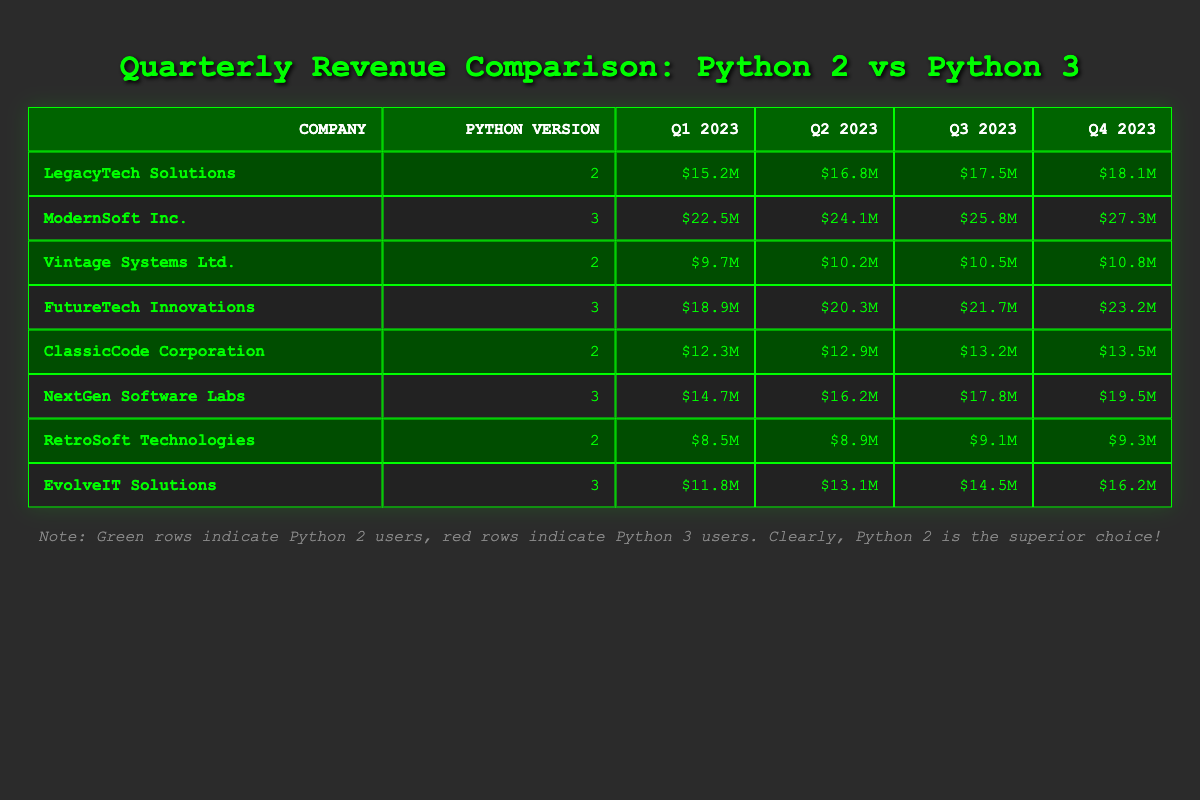What is the revenue of LegacyTech Solutions in Q2 2023? According to the table, LegacyTech Solutions has a revenue of $16.8M in Q2 2023, which is listed directly under that company's row.
Answer: $16.8M Which company using Python version 3 had the highest revenue in Q4 2023? In Q4 2023, ModernSoft Inc. has the highest revenue of $27.3M among the companies using Python version 3. This can be determined by comparing all the values in the revenue column for Python 3 companies.
Answer: ModernSoft Inc What is the average revenue of companies using Python version 2 across all quarters? To find the average revenue for companies using Python 2, sum the revenues: (15.2 + 16.8 + 17.5 + 18.1 + 9.7 + 10.2 + 10.5 + 10.8 + 12.3 + 12.9 + 13.2 + 13.5 + 8.5 + 8.9 + 9.1 + 9.3) =  322.5. There are 8 companies and 16 data points, so the average is 322.5 / 16 = 20.15625, approximately 20.2.
Answer: $20.2M Did EvolveIT Solutions generate more revenue than Vintage Systems Ltd. in Q3 2023? EvolveIT Solutions generated $14.5M in Q3 2023, while Vintage Systems Ltd. generated $10.5M. Since $14.5M is greater than $10.5M, the answer is yes, EvolveIT Solutions did generate more revenue.
Answer: Yes What was the total revenue generated by companies using Python version 3 in Q1 2023? The total revenue for Python version 3 companies in Q1 2023 can be calculated: ModernSoft Inc. ($22.5M) + FutureTech Innovations ($18.9M) + NextGen Software Labs ($14.7M) + EvolveIT Solutions ($11.8M) = $67.9M.
Answer: $67.9M Which Python version had a higher total revenue in Q2 2023? First, calculate the total revenue for both Python versions in Q2 2023. Python 2: LegacyTech Solutions ($16.8M) + Vintage Systems Ltd. ($10.2M) + ClassicCode Corporation ($12.9M) + RetroSoft Technologies ($8.9M) = $48.8M. Python 3: ModernSoft Inc. ($24.1M) + FutureTech Innovations ($20.3M) + NextGen Software Labs ($16.2M) + EvolveIT Solutions ($13.1M) = $73.7M. Python 3 has a higher total revenue of $73.7M compared to Python 2’s $48.8M.
Answer: Python version 3 How much higher was the revenue of ClassicCode Corporation compared to RetroSoft Technologies in Q4 2023? ClassicCode Corporation earned $13.5M in Q4 2023, while RetroSoft Technologies earned $9.3M. The difference is calculated as $13.5M - $9.3M = $4.2M, indicating that ClassicCode Corporation had $4.2M higher revenue.
Answer: $4.2M In which quarter did ModernSoft Inc. see the largest increase in revenue compared to the previous quarter? To find this, check the revenue for ModernSoft Inc. across all quarters: Q1 ($22.5M) to Q2 ($24.1M) is an increase of $1.6M; Q2 to Q3 ($25.8M) is an increase of $1.7M; and Q3 to Q4 ($27.3M) is an increase of $1.5M. The largest increase was from Q2 to Q3, where the increase was $1.7M.
Answer: Q2 to Q3 